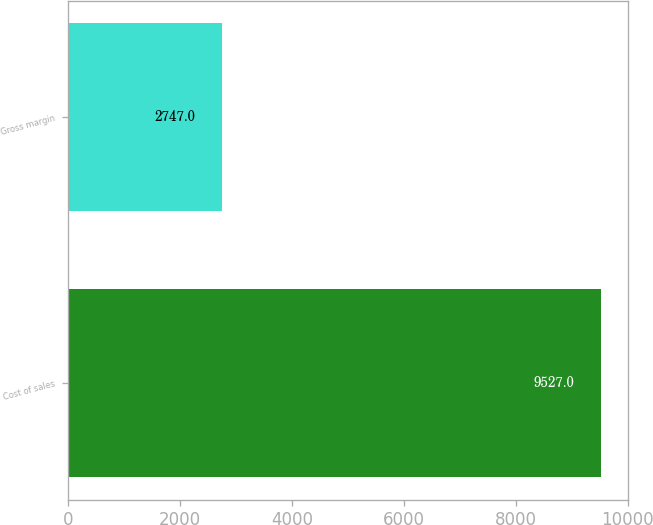Convert chart. <chart><loc_0><loc_0><loc_500><loc_500><bar_chart><fcel>Cost of sales<fcel>Gross margin<nl><fcel>9527<fcel>2747<nl></chart> 